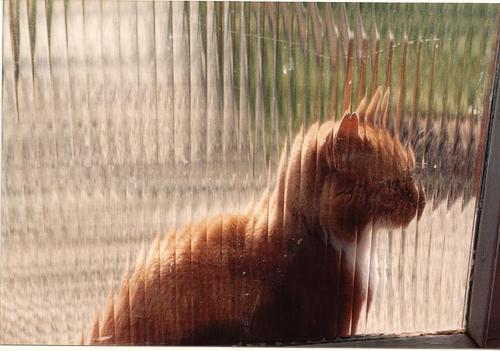How many ears does the cat have?
Give a very brief answer. 2. 